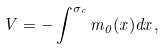Convert formula to latex. <formula><loc_0><loc_0><loc_500><loc_500>V = - \int ^ { \sigma _ { c } } m _ { 0 } ( x ) d x ,</formula> 